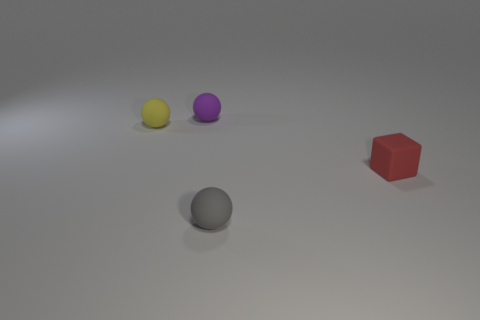Add 4 cyan rubber cubes. How many objects exist? 8 Subtract all cubes. How many objects are left? 3 Add 4 small gray objects. How many small gray objects exist? 5 Subtract 0 gray cubes. How many objects are left? 4 Subtract all purple matte spheres. Subtract all tiny shiny cylinders. How many objects are left? 3 Add 4 purple matte spheres. How many purple matte spheres are left? 5 